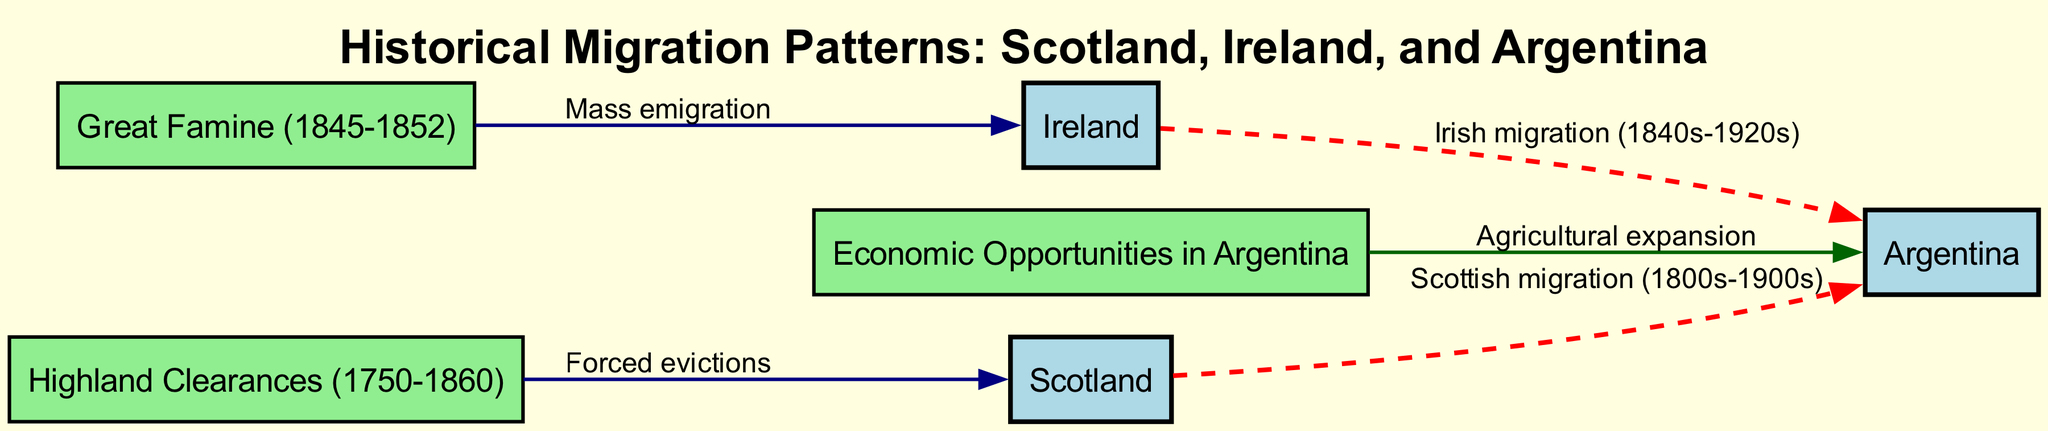What are the three key locations represented in the diagram? The nodes in the diagram represent Scotland, Ireland, and Argentina. Each of these locations plays a significant role in the migration patterns depicted.
Answer: Scotland, Ireland, Argentina How many total nodes are in the diagram? The diagram contains six nodes, which include the three locations and the three key events related to migration.
Answer: 6 What event is associated with mass emigration from Ireland? The diagram shows the Great Famine (1845-1852) as the event that caused mass emigration from Ireland.
Answer: Great Famine Which migration originates from Scotland? The diagram indicates that Scottish migration to Argentina took place primarily in the 1800s to 1900s.
Answer: Scottish migration What are the reasons for migration from Ireland to Argentina? The edges in the diagram show that Irish migration to Argentina was influenced by both the Great Famine and the search for economic opportunities.
Answer: Great Famine, Economic Opportunities How did economic opportunities impact migration patterns? Economic opportunities in Argentina, particularly related to agricultural expansion, were a key motivator for migration from both Scotland and Ireland. The diagram links economic opportunities directly to Argentina.
Answer: Agricultural expansion Which historical event led to forced evictions from Scotland? The Highland Clearances (1750-1860) resulted in forced evictions, which significantly affected Scottish populations and contributed to their migration patterns.
Answer: Highland Clearances What defines the nature of the edges connecting Scotland and Ireland to Argentina? The edges connecting these nodes to Argentina are dashed lines, indicating migration flows, specifically highlighting the movement from Scotland and Ireland to Argentina during their respective time periods.
Answer: Dashed lines What period is directly associated with Irish migration shown in the diagram? The diagram points out that Irish migration occurred from the 1840s to the 1920s, marking a significant timeframe for the immigration patterns from Ireland to Argentina.
Answer: 1840s-1920s 